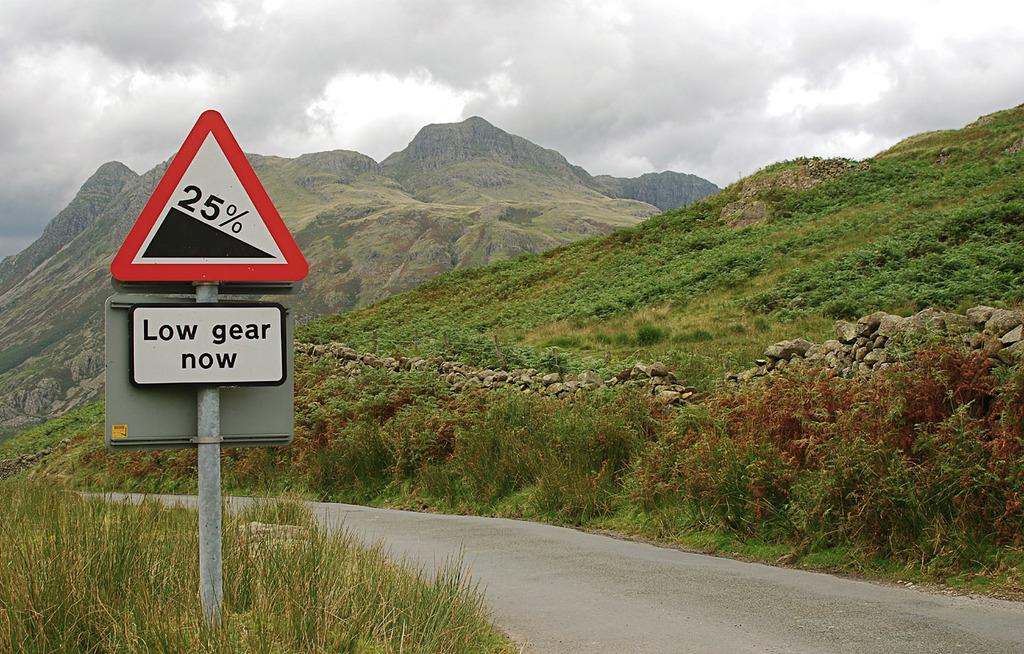<image>
Present a compact description of the photo's key features. The street sign indicates there is a 25% slope and to use low gear now. 